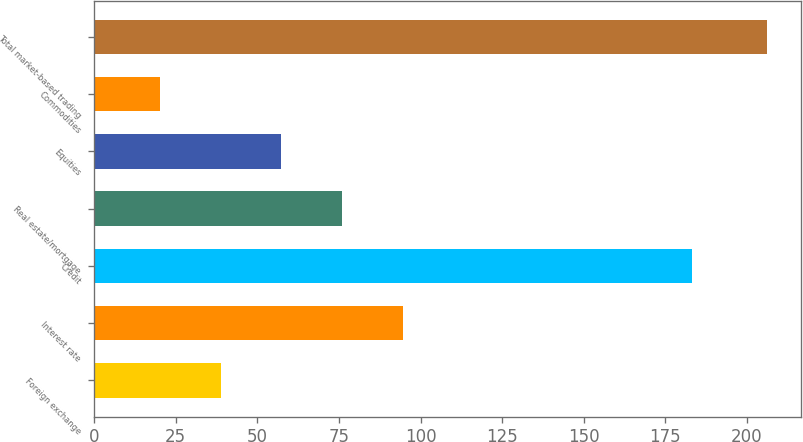Convert chart to OTSL. <chart><loc_0><loc_0><loc_500><loc_500><bar_chart><fcel>Foreign exchange<fcel>Interest rate<fcel>Credit<fcel>Real estate/mortgage<fcel>Equities<fcel>Commodities<fcel>Total market-based trading<nl><fcel>38.8<fcel>94.6<fcel>183.3<fcel>76<fcel>57.4<fcel>20.2<fcel>206.2<nl></chart> 